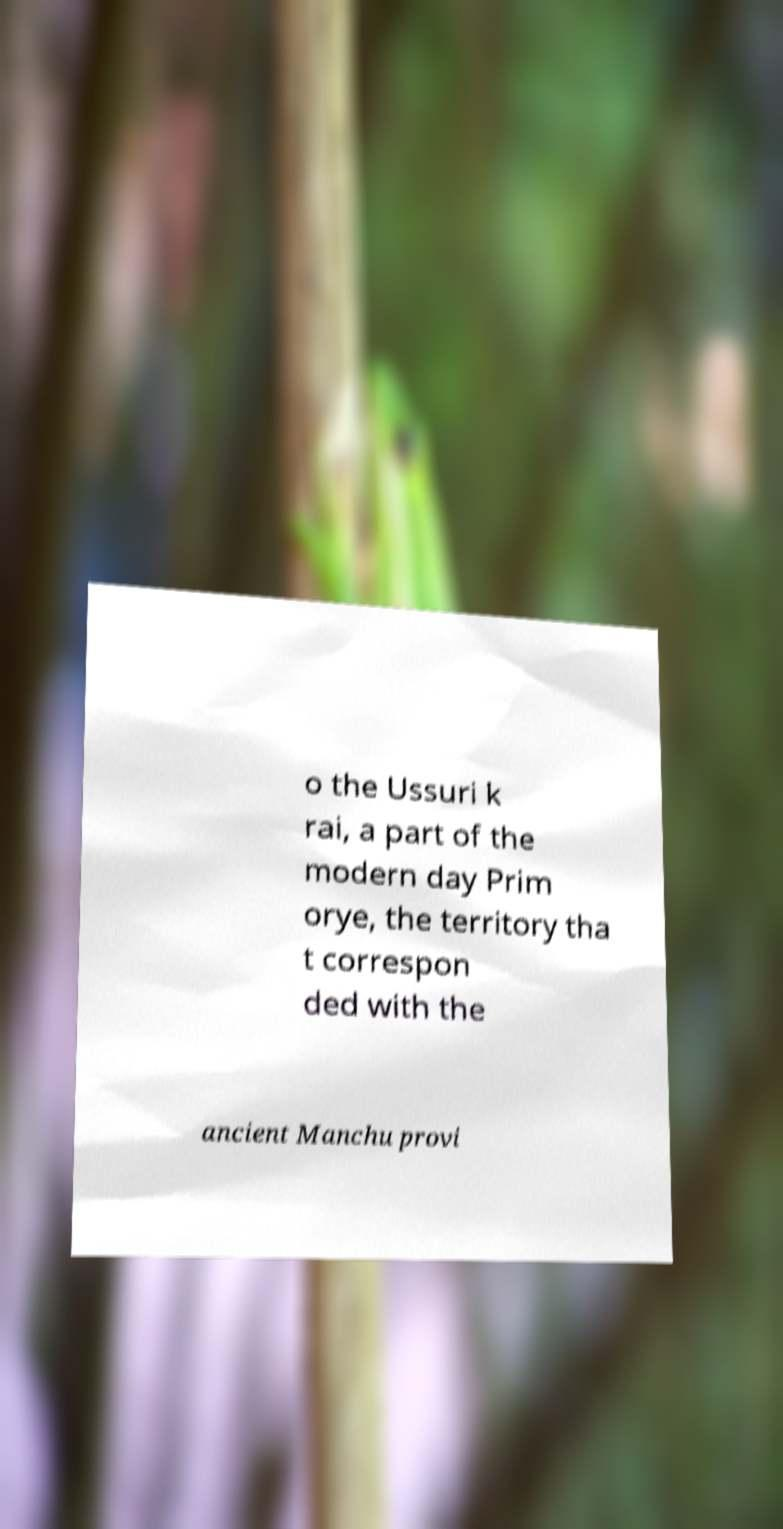Please identify and transcribe the text found in this image. o the Ussuri k rai, a part of the modern day Prim orye, the territory tha t correspon ded with the ancient Manchu provi 